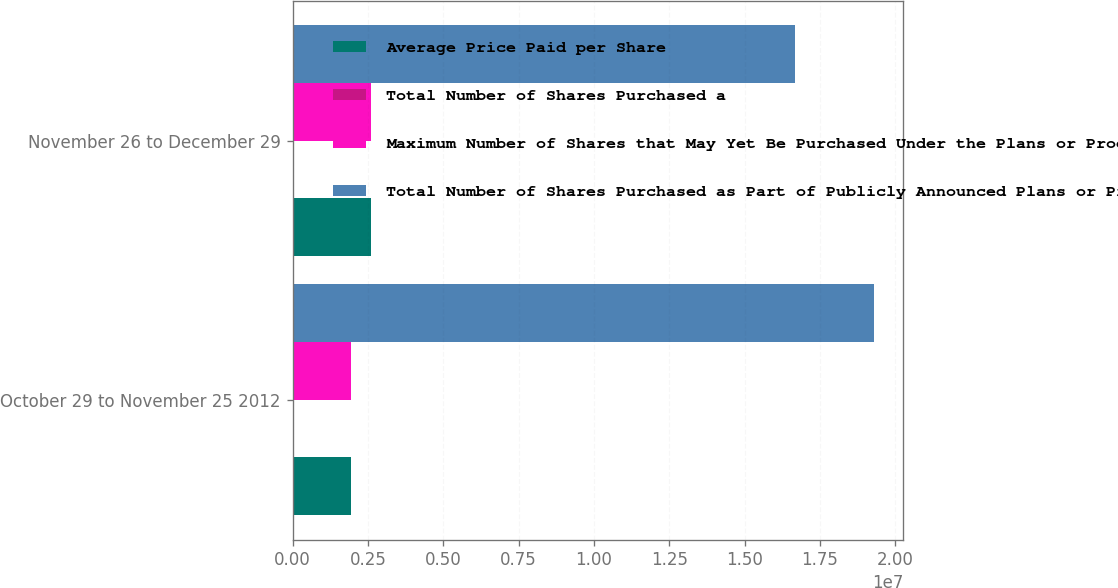<chart> <loc_0><loc_0><loc_500><loc_500><stacked_bar_chart><ecel><fcel>October 29 to November 25 2012<fcel>November 26 to December 29<nl><fcel>Average Price Paid per Share<fcel>1.94753e+06<fcel>2.60981e+06<nl><fcel>Total Number of Shares Purchased a<fcel>43.9<fcel>44.5<nl><fcel>Maximum Number of Shares that May Yet Be Purchased Under the Plans or Programs b<fcel>1.94753e+06<fcel>2.60981e+06<nl><fcel>Total Number of Shares Purchased as Part of Publicly Announced Plans or Programs a<fcel>1.92962e+07<fcel>1.66864e+07<nl></chart> 